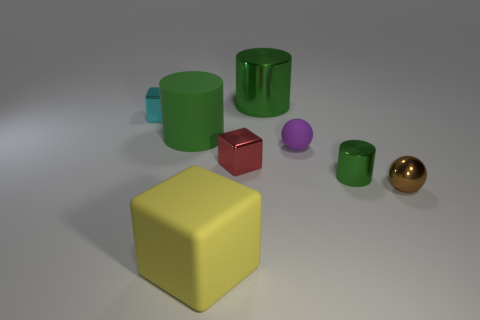Could you guess the texture of these objects? The objects seem to have smooth and glossy textures, indicative of surfaces that are likely hard and reflective, similar to polished plastic or glass. 